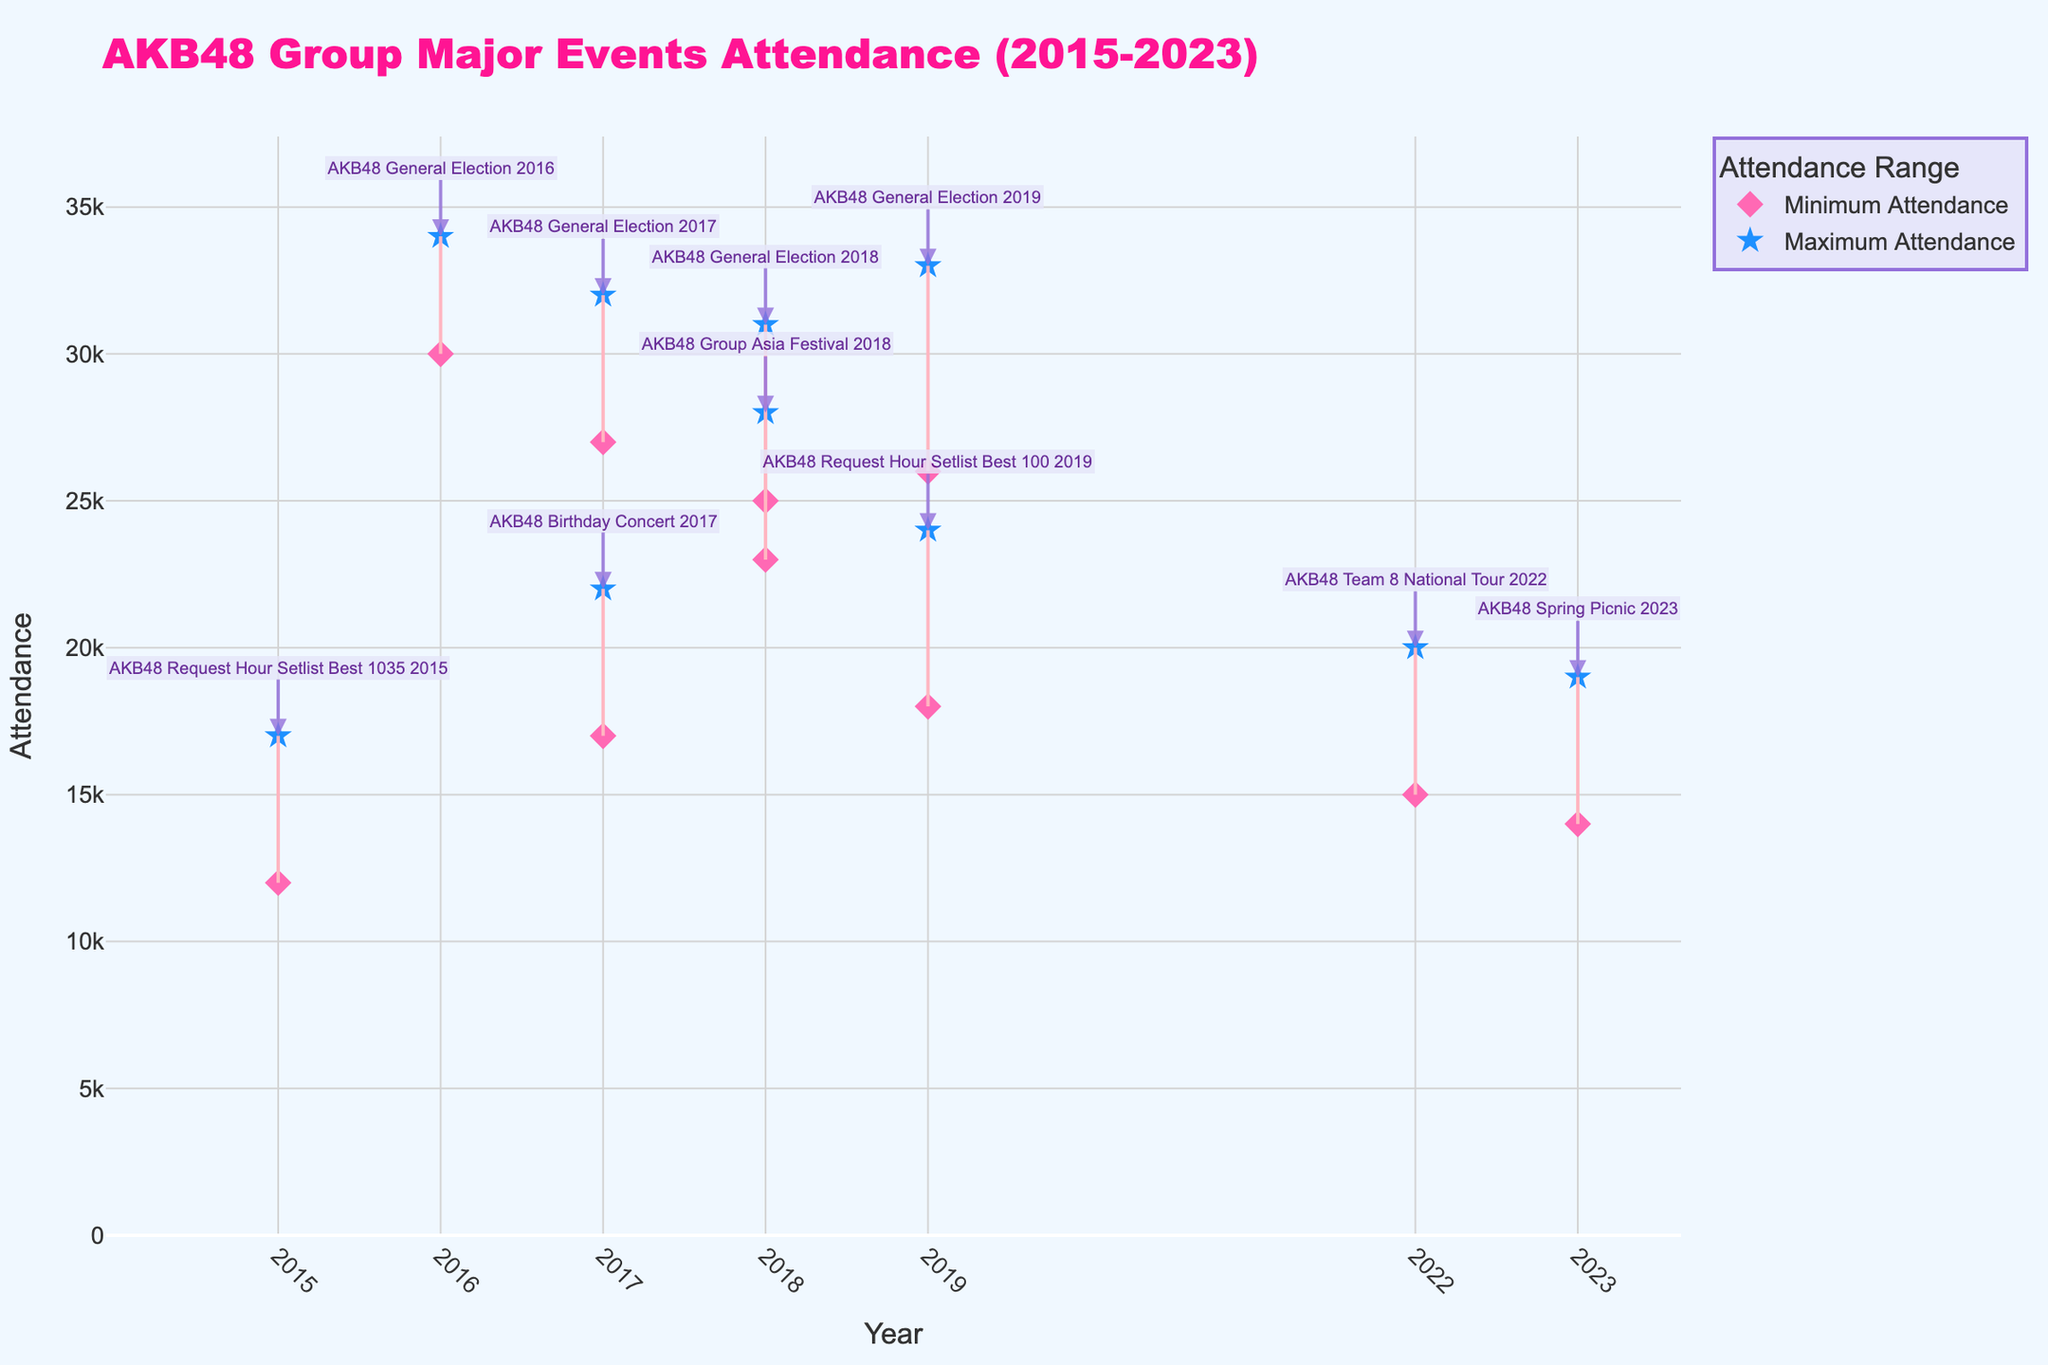Which event had the highest maximum attendance in the given time period? The event with the highest maximum attendance can be identified by looking at the star markers on the plot. The event with the highest star marker value is "AKB48 General Election 2016" with a maximum attendance of 34,000.
Answer: AKB48 General Election 2016 Which year had the smallest range of attendance between the minimum and maximum values? The smallest range of attendance can be found by calculating the difference between the maximum and minimum attendance for each year and finding the year with the smallest difference. In 2022, the difference is 5,000 (15,000 to 20,000), which is the smallest range.
Answer: 2022 What is the difference in maximum attendance between "AKB48 Group Asia Festival 2018" and "AKB48 Team 8 National Tour 2022"? To find the difference in maximum attendance, subtract the maximum attendance of "AKB48 Team 8 National Tour 2022" (20,000) from "AKB48 Group Asia Festival 2018" (28,000). This gives 28,000 - 20,000 = 8,000.
Answer: 8,000 Between 2017 and 2019, which year had the highest minimum attendance for any event? You need to compare the minimum attendance values from 2017, 2018, and 2019. The highest minimum value among these years is from "AKB48 General Election 2019" in 2019, which is 26,000.
Answer: 2019 What is the average minimum attendance of all events in 2018? To calculate the average minimum attendance for 2018, sum the minimum attendance values for the two events (23,000 for Asia Festival and 25,000 for General Election) and divide by 2. This gives (23,000 + 25,000) / 2 = 24,000.
Answer: 24,000 Which event in 2015 had a maximum attendance, and what was its value? The event in 2015 can be identified from the plot annotations and its maximum attendance can be confirmed by looking at the highest star markers for that year. The event is "AKB48 Request Hour Setlist Best 1035 2015" and its maximum attendance is 17,000.
Answer: AKB48 Request Hour Setlist Best 1035 2015, 17,000 How many events had a minimum attendance of 20,000 or more? Count the number of markers (diamonds) that represent minimum attendance values greater than or equal to 20,000. These events are seen in 2016, 2017 (Birthday Concert and General Election), 2018 (both events), and 2019 (Request Hour and General Election). There are 6 events in total.
Answer: 6 Which event had the largest range of attendance values, and what was the range? The event with the largest range can be found by calculating the difference between the maximum and minimum for each event and identifying the largest difference. "AKB48 General Election 2019" has the largest range with a difference of 7,000 (33,000 - 26,000).
Answer: AKB48 General Election 2019, 7,000 